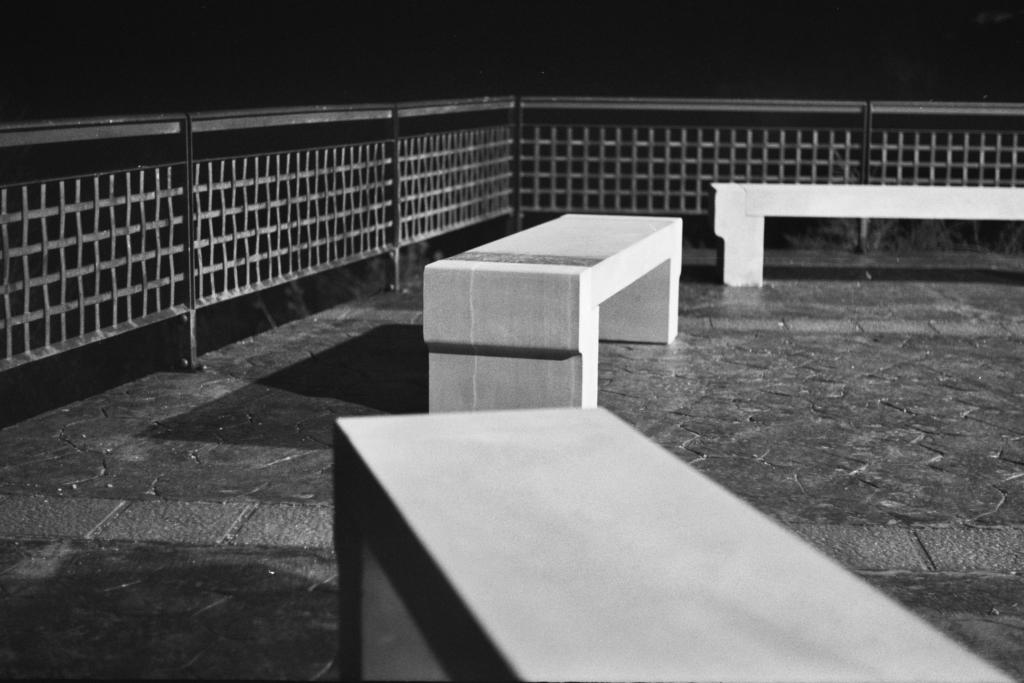What type of seating is visible in the image? There are concrete benches in the image. On what surface are the benches placed? The benches are on a surface. What is located behind the benches? There is a closed metal fencing behind the benches. How many fish can be seen swimming in the vest in the image? There are no fish or vests present in the image. 